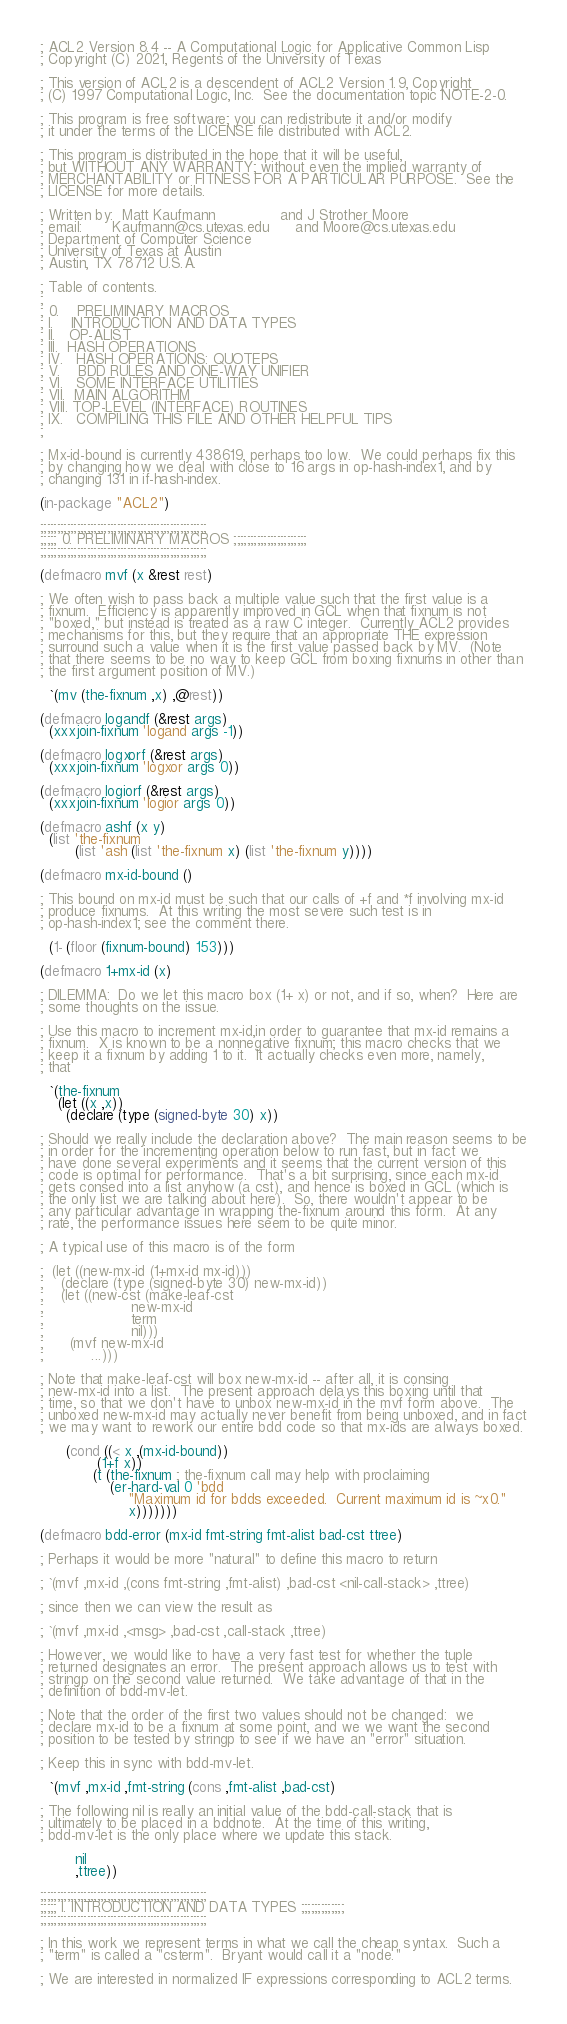<code> <loc_0><loc_0><loc_500><loc_500><_Lisp_>; ACL2 Version 8.4 -- A Computational Logic for Applicative Common Lisp
; Copyright (C) 2021, Regents of the University of Texas

; This version of ACL2 is a descendent of ACL2 Version 1.9, Copyright
; (C) 1997 Computational Logic, Inc.  See the documentation topic NOTE-2-0.

; This program is free software; you can redistribute it and/or modify
; it under the terms of the LICENSE file distributed with ACL2.

; This program is distributed in the hope that it will be useful,
; but WITHOUT ANY WARRANTY; without even the implied warranty of
; MERCHANTABILITY or FITNESS FOR A PARTICULAR PURPOSE.  See the
; LICENSE for more details.

; Written by:  Matt Kaufmann               and J Strother Moore
; email:       Kaufmann@cs.utexas.edu      and Moore@cs.utexas.edu
; Department of Computer Science
; University of Texas at Austin
; Austin, TX 78712 U.S.A.

; Table of contents.
;
; 0.    PRELIMINARY MACROS
; I.    INTRODUCTION AND DATA TYPES
; II.   OP-ALIST
; III.  HASH OPERATIONS
; IV.   HASH OPERATIONS: QUOTEPS
; V.    BDD RULES AND ONE-WAY UNIFIER
; VI.   SOME INTERFACE UTILITIES
; VII.  MAIN ALGORITHM
; VIII. TOP-LEVEL (INTERFACE) ROUTINES
; IX.   COMPILING THIS FILE AND OTHER HELPFUL TIPS
;

; Mx-id-bound is currently 438619, perhaps too low.  We could perhaps fix this
; by changing how we deal with close to 16 args in op-hash-index1, and by
; changing 131 in if-hash-index.

(in-package "ACL2")

;;;;;;;;;;;;;;;;;;;;;;;;;;;;;;;;;;;;;;;;;;;;;;;;;;
;;;;; 0. PRELIMINARY MACROS ;;;;;;;;;;;;;;;;;;;;;;
;;;;;;;;;;;;;;;;;;;;;;;;;;;;;;;;;;;;;;;;;;;;;;;;;;

(defmacro mvf (x &rest rest)

; We often wish to pass back a multiple value such that the first value is a
; fixnum.  Efficiency is apparently improved in GCL when that fixnum is not
; "boxed," but instead is treated as a raw C integer.  Currently ACL2 provides
; mechanisms for this, but they require that an appropriate THE expression
; surround such a value when it is the first value passed back by MV.  (Note
; that there seems to be no way to keep GCL from boxing fixnums in other than
; the first argument position of MV.)

  `(mv (the-fixnum ,x) ,@rest))

(defmacro logandf (&rest args)
  (xxxjoin-fixnum 'logand args -1))

(defmacro logxorf (&rest args)
  (xxxjoin-fixnum 'logxor args 0))

(defmacro logiorf (&rest args)
  (xxxjoin-fixnum 'logior args 0))

(defmacro ashf (x y)
  (list 'the-fixnum
        (list 'ash (list 'the-fixnum x) (list 'the-fixnum y))))

(defmacro mx-id-bound ()

; This bound on mx-id must be such that our calls of +f and *f involving mx-id
; produce fixnums.  At this writing the most severe such test is in
; op-hash-index1; see the comment there.

  (1- (floor (fixnum-bound) 153)))

(defmacro 1+mx-id (x)

; DILEMMA:  Do we let this macro box (1+ x) or not, and if so, when?  Here are
; some thoughts on the issue.

; Use this macro to increment mx-id,in order to guarantee that mx-id remains a
; fixnum.  X is known to be a nonnegative fixnum; this macro checks that we
; keep it a fixnum by adding 1 to it.  It actually checks even more, namely,
; that

  `(the-fixnum
    (let ((x ,x))
      (declare (type (signed-byte 30) x))

; Should we really include the declaration above?  The main reason seems to be
; in order for the incrementing operation below to run fast, but in fact we
; have done several experiments and it seems that the current version of this
; code is optimal for performance.  That's a bit surprising, since each mx-id
; gets consed into a list anyhow (a cst), and hence is boxed in GCL (which is
; the only list we are talking about here).  So, there wouldn't appear to be
; any particular advantage in wrapping the-fixnum around this form.  At any
; rate, the performance issues here seem to be quite minor.

; A typical use of this macro is of the form

;  (let ((new-mx-id (1+mx-id mx-id)))
;    (declare (type (signed-byte 30) new-mx-id))
;    (let ((new-cst (make-leaf-cst
;                    new-mx-id
;                    term
;                    nil)))
;      (mvf new-mx-id
;           ...)))

; Note that make-leaf-cst will box new-mx-id -- after all, it is consing
; new-mx-id into a list.  The present approach delays this boxing until that
; time, so that we don't have to unbox new-mx-id in the mvf form above.  The
; unboxed new-mx-id may actually never benefit from being unboxed, and in fact
; we may want to rework our entire bdd code so that mx-ids are always boxed.

      (cond ((< x ,(mx-id-bound))
             (1+f x))
            (t (the-fixnum ; the-fixnum call may help with proclaiming
                (er-hard-val 0 'bdd
                    "Maximum id for bdds exceeded.  Current maximum id is ~x0."
                    x)))))))

(defmacro bdd-error (mx-id fmt-string fmt-alist bad-cst ttree)

; Perhaps it would be more "natural" to define this macro to return

; `(mvf ,mx-id ,(cons fmt-string ,fmt-alist) ,bad-cst <nil-call-stack> ,ttree)

; since then we can view the result as

; `(mvf ,mx-id ,<msg> ,bad-cst ,call-stack ,ttree)

; However, we would like to have a very fast test for whether the tuple
; returned designates an error.  The present approach allows us to test with
; stringp on the second value returned.  We take advantage of that in the
; definition of bdd-mv-let.

; Note that the order of the first two values should not be changed:  we
; declare mx-id to be a fixnum at some point, and we we want the second
; position to be tested by stringp to see if we have an "error" situation.

; Keep this in sync with bdd-mv-let.

  `(mvf ,mx-id ,fmt-string (cons ,fmt-alist ,bad-cst)

; The following nil is really an initial value of the bdd-call-stack that is
; ultimately to be placed in a bddnote.  At the time of this writing,
; bdd-mv-let is the only place where we update this stack.

        nil
        ,ttree))

;;;;;;;;;;;;;;;;;;;;;;;;;;;;;;;;;;;;;;;;;;;;;;;;;;
;;;;; I. INTRODUCTION AND DATA TYPES ;;;;;;;;;;;;;
;;;;;;;;;;;;;;;;;;;;;;;;;;;;;;;;;;;;;;;;;;;;;;;;;;

; In this work we represent terms in what we call the cheap syntax.  Such a
; "term" is called a "csterm".  Bryant would call it a "node."

; We are interested in normalized IF expressions corresponding to ACL2 terms.</code> 